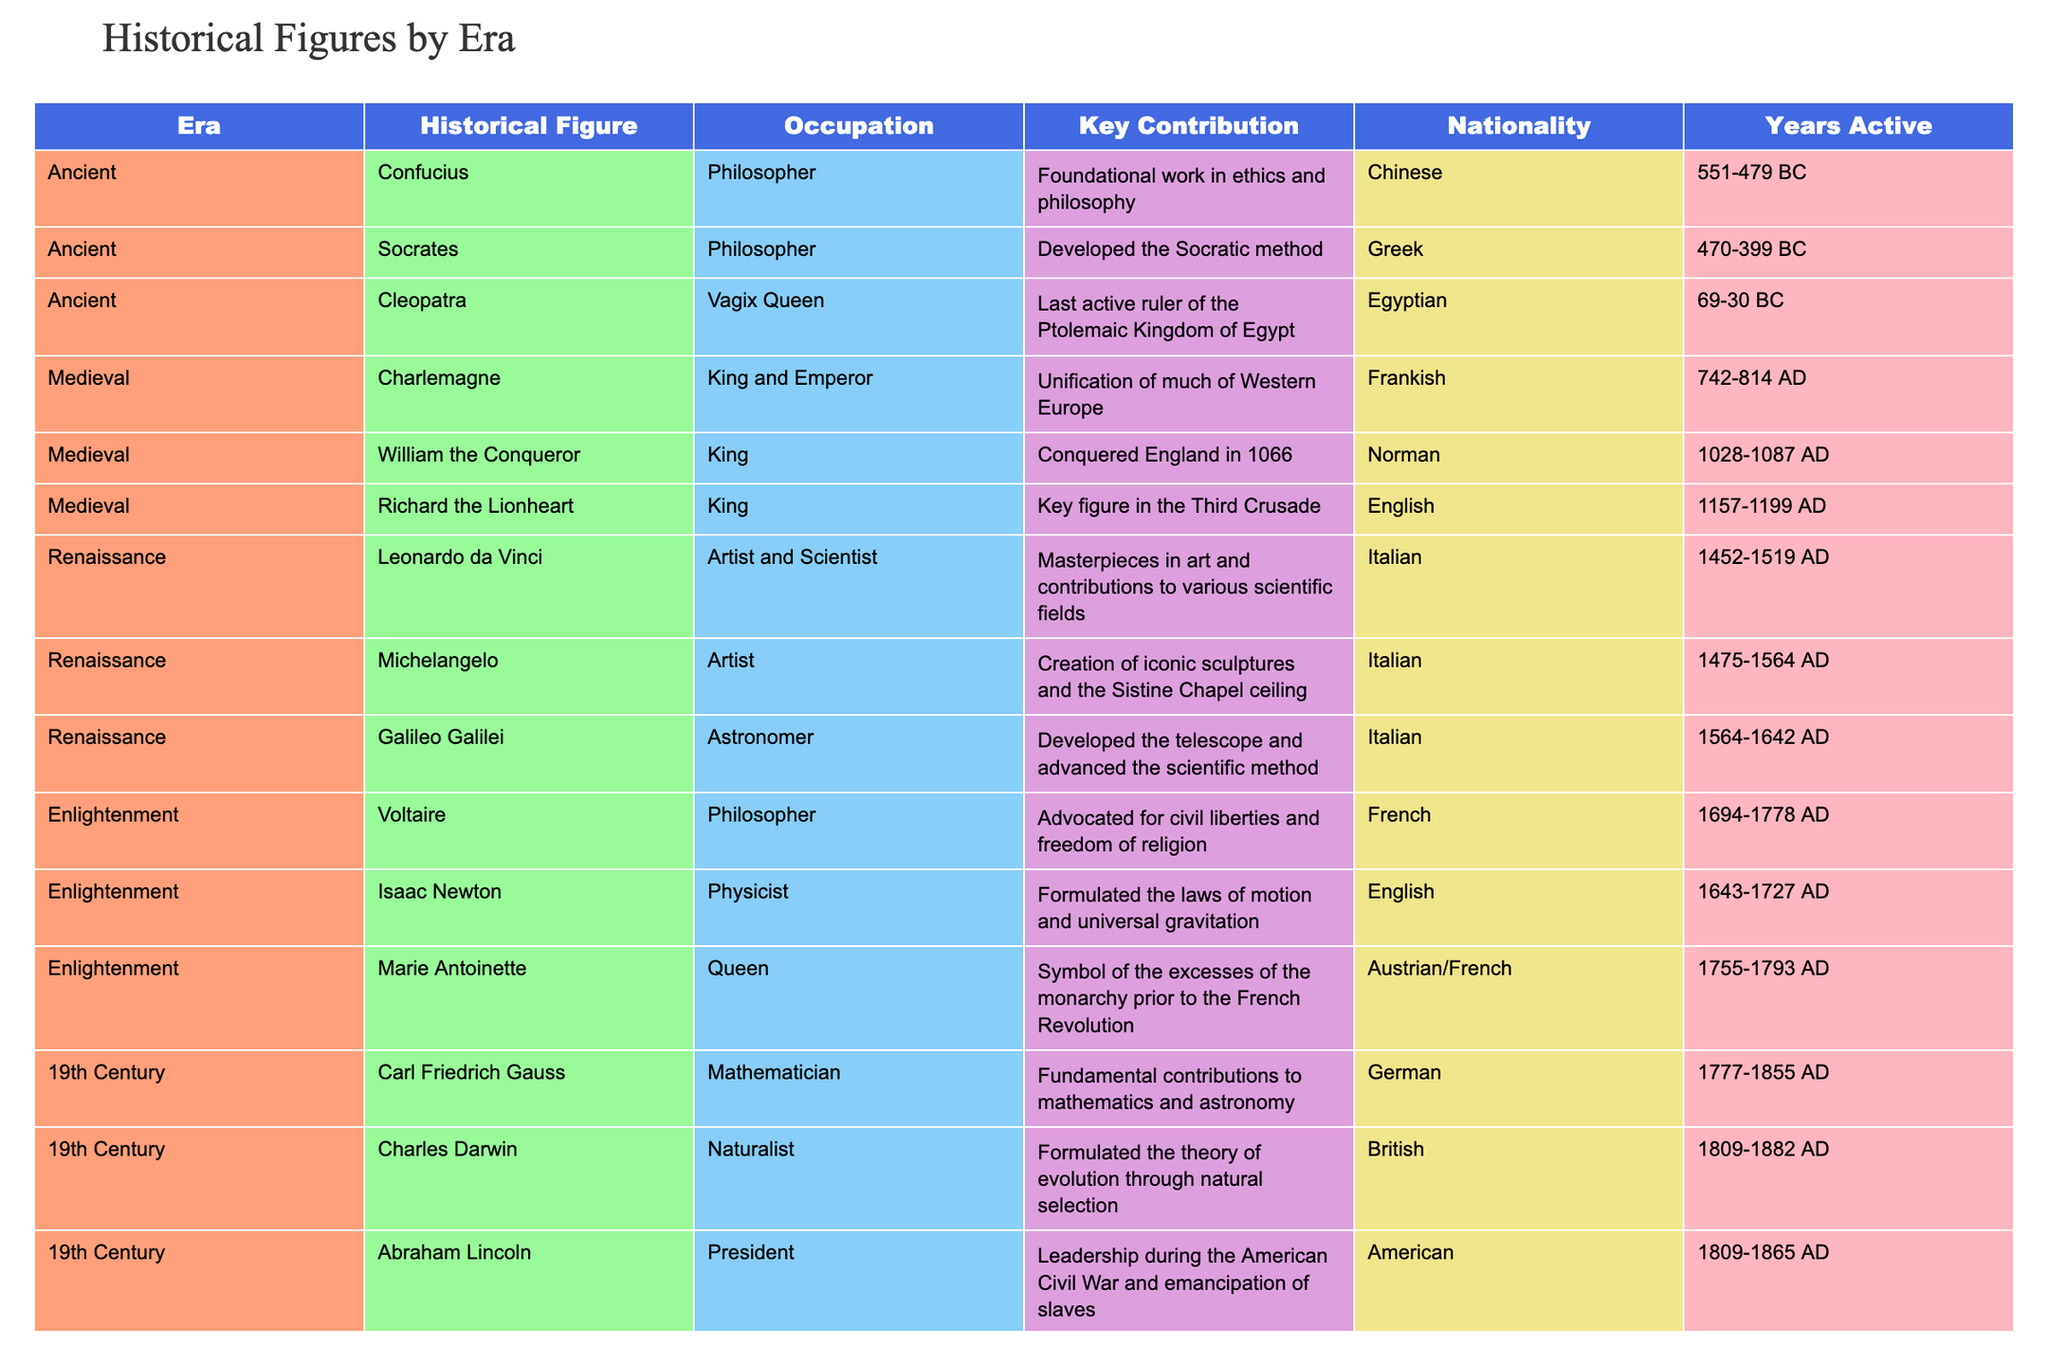What was the key contribution of Abraham Lincoln? Abraham Lincoln's key contribution was his leadership during the American Civil War and the emancipation of slaves, as stated in the table under the "Key Contribution" column.
Answer: Leadership during the Civil War and emancipation Which historical figure was active in the Enlightenment and contributed to civil liberties? Voltaire is the historical figure who was an Enlightenment philosopher advocating for civil liberties and is listed in the table under the Enlightenment era.
Answer: Voltaire How many historical figures were active in the 19th Century? By counting the entries under the "19th Century" era in the table, there are three figures: Carl Friedrich Gauss, Charles Darwin, and Abraham Lincoln.
Answer: Three Which nationality had the most prominent figures in the Renaissance era and who were they? The table contains three prominent figures from Italy during the Renaissance, specifically Leonardo da Vinci, Michelangelo, and Galileo Galilei, indicating that Italy had the most figures in this era.
Answer: Italy: Leonardo da Vinci, Michelangelo, Galileo Galilei Is Marie Antoinette associated with the French Revolution? Yes, Marie Antoinette is associated with the French Revolution as she symbolizes the excesses of the monarchy prior to the revolution, according to the information in the table.
Answer: Yes Who was the first African American president of the United States? The table specifies Barack Obama as the first African American president of the United States in the 21st Century section.
Answer: Barack Obama Calculate the average years active for historical figures in the Ancient era. The figures in the Ancient era are Confucius (551-479 BC; 73 years), Socrates (470-399 BC; 71 years), and Cleopatra (69-30 BC; 39 years). Summing these gives 73 + 71 + 39 = 183 years. There are three figures, so the average is 183/3 = 61 years.
Answer: 61 years Who was a key figure in the Third Crusade? The table specifically lists Richard the Lionheart as a key figure in the Third Crusade, which directly answers the question based on the "Key Contribution" column.
Answer: Richard the Lionheart How long was Mahatma Gandhi active in his role as a political leader? Mahatma Gandhi was active from 1869 until 1948, which means he was active for 79 years. This is calculated by taking the difference between 1948 and 1869 since "Present" is generally understood as the end of his legacy in this context.
Answer: 79 years 